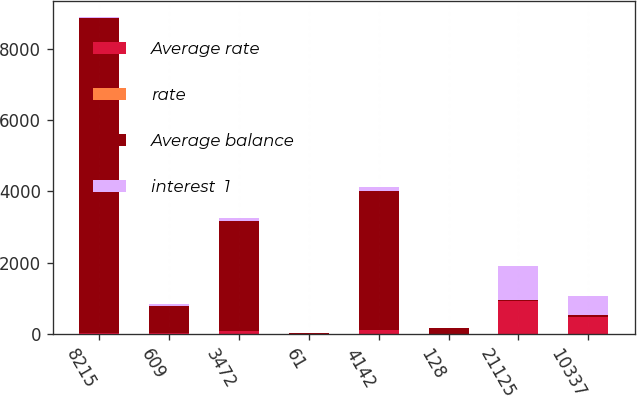<chart> <loc_0><loc_0><loc_500><loc_500><stacked_bar_chart><ecel><fcel>8215<fcel>609<fcel>3472<fcel>61<fcel>4142<fcel>128<fcel>21125<fcel>10337<nl><fcel>Average rate<fcel>21.4<fcel>32.1<fcel>75.3<fcel>2<fcel>109.4<fcel>4.6<fcel>922.6<fcel>483.7<nl><fcel>rate<fcel>0.26<fcel>5.27<fcel>2.17<fcel>3.22<fcel>2.64<fcel>3.63<fcel>4.37<fcel>4.68<nl><fcel>Average balance<fcel>8850<fcel>762<fcel>3107<fcel>32<fcel>3901<fcel>147<fcel>32.05<fcel>32.05<nl><fcel>interest  1<fcel>23.4<fcel>37.4<fcel>72.2<fcel>1.1<fcel>110.7<fcel>5.3<fcel>940.8<fcel>556.4<nl></chart> 